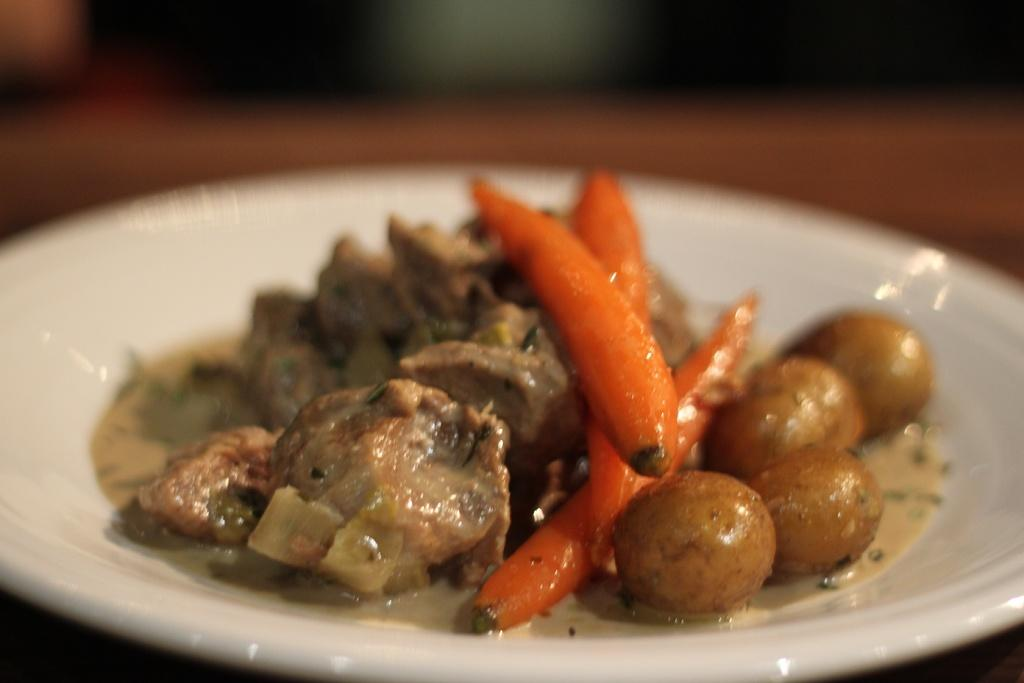What is on the plate in the image? There are food items on a plate in the image. Can you describe the background of the image? The background of the image is blurred. Where is your uncle sitting on the swing in the image? There is no uncle or swing present in the image. 